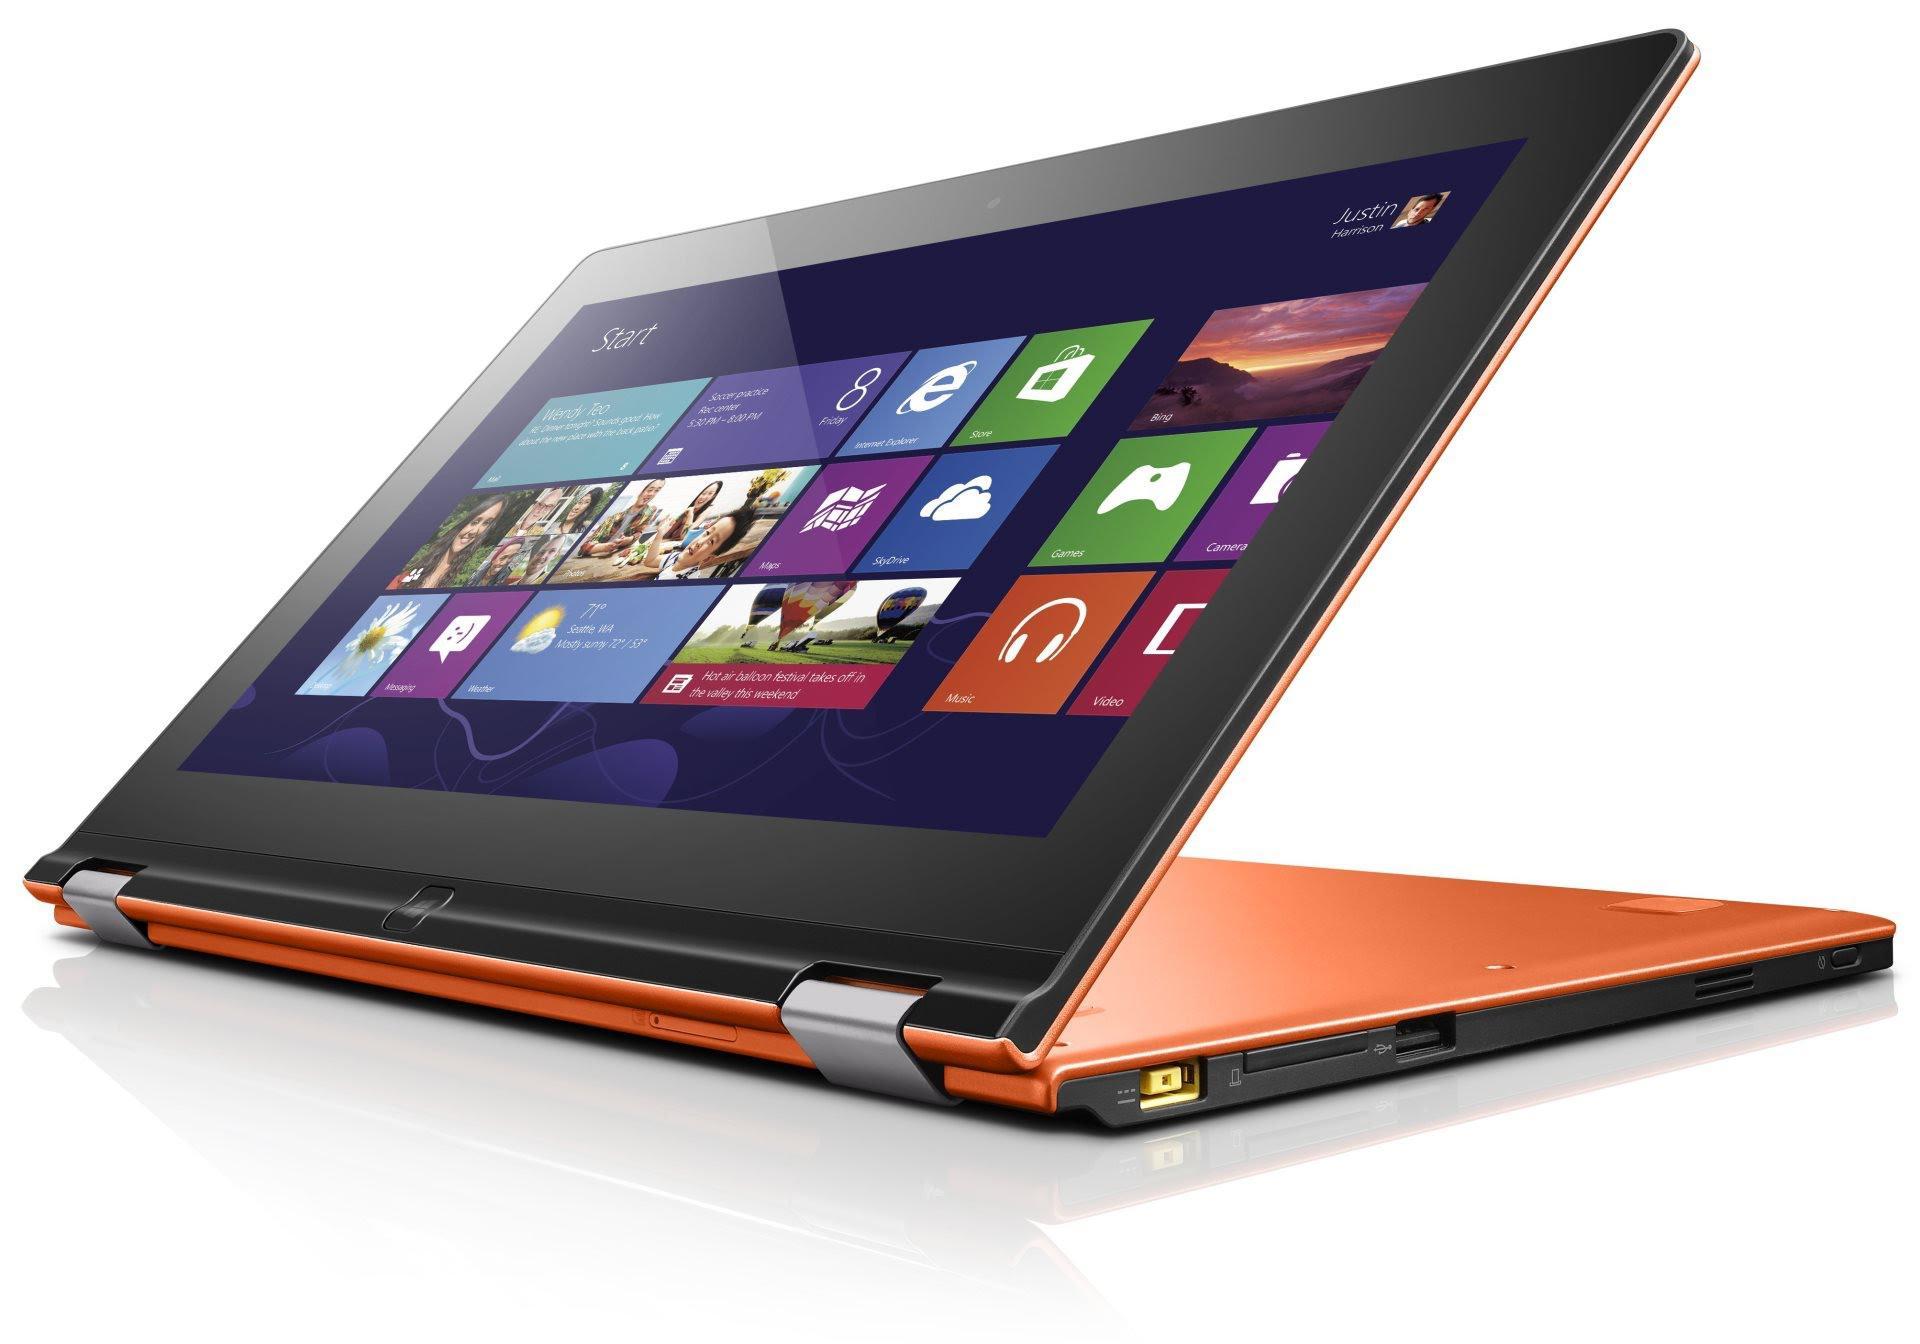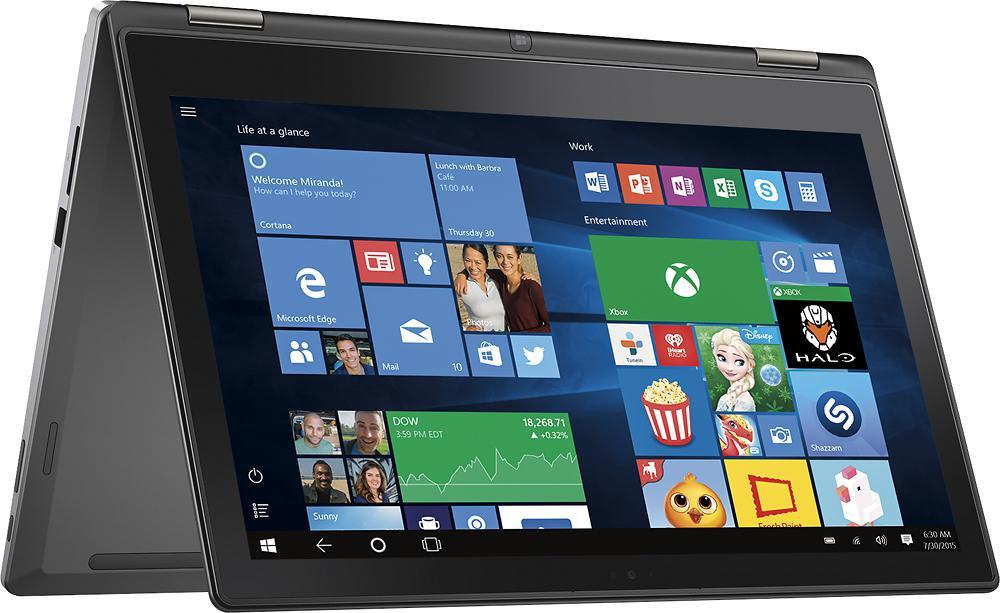The first image is the image on the left, the second image is the image on the right. Examine the images to the left and right. Is the description "There are more than two computers in total." accurate? Answer yes or no. No. 